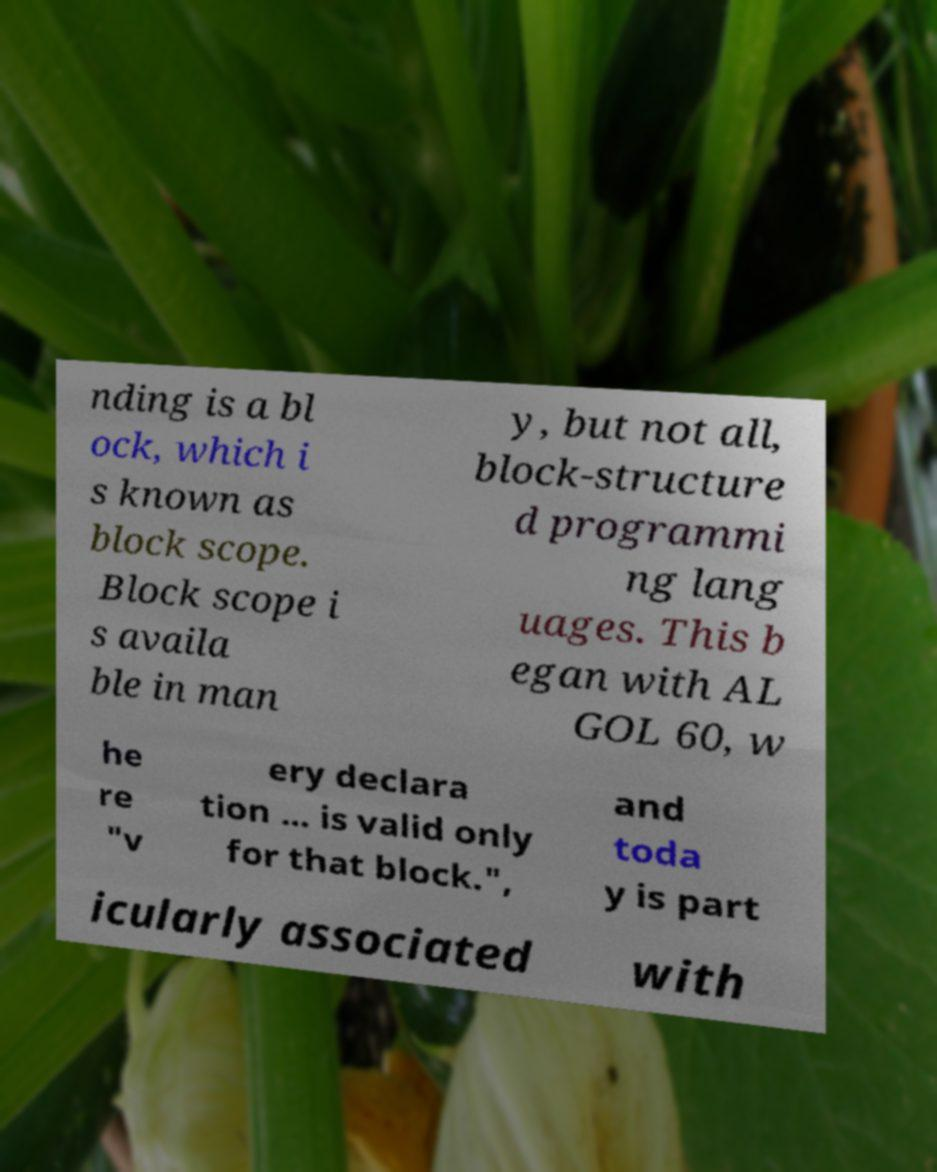Could you assist in decoding the text presented in this image and type it out clearly? nding is a bl ock, which i s known as block scope. Block scope i s availa ble in man y, but not all, block-structure d programmi ng lang uages. This b egan with AL GOL 60, w he re "v ery declara tion ... is valid only for that block.", and toda y is part icularly associated with 